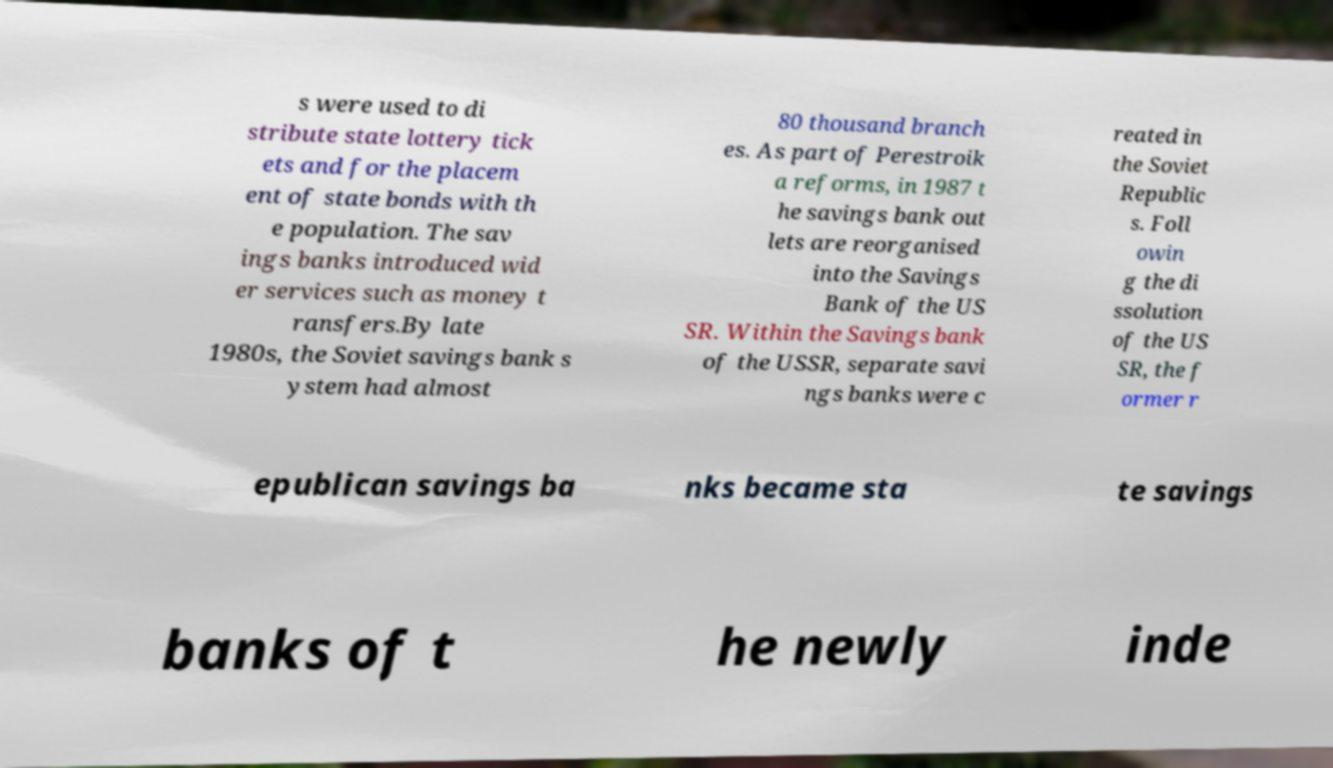Please identify and transcribe the text found in this image. s were used to di stribute state lottery tick ets and for the placem ent of state bonds with th e population. The sav ings banks introduced wid er services such as money t ransfers.By late 1980s, the Soviet savings bank s ystem had almost 80 thousand branch es. As part of Perestroik a reforms, in 1987 t he savings bank out lets are reorganised into the Savings Bank of the US SR. Within the Savings bank of the USSR, separate savi ngs banks were c reated in the Soviet Republic s. Foll owin g the di ssolution of the US SR, the f ormer r epublican savings ba nks became sta te savings banks of t he newly inde 